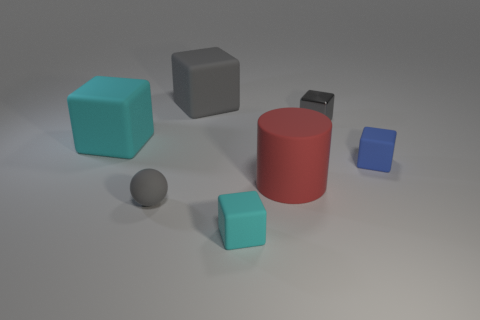Is the number of big brown metallic cylinders less than the number of blocks?
Your answer should be compact. Yes. Are there any other things that are the same color as the metallic object?
Give a very brief answer. Yes. What is the shape of the gray object that is in front of the red rubber cylinder?
Your answer should be very brief. Sphere. Do the small matte ball and the rubber cube that is on the right side of the red object have the same color?
Provide a short and direct response. No. Is the number of small cyan things that are behind the tiny matte sphere the same as the number of big gray matte blocks in front of the tiny metallic block?
Give a very brief answer. Yes. How many other objects are the same size as the gray metal block?
Provide a short and direct response. 3. The metallic block is what size?
Offer a terse response. Small. Do the big cylinder and the cyan cube behind the blue rubber block have the same material?
Your response must be concise. Yes. Is there a rubber object that has the same shape as the gray metallic thing?
Offer a terse response. Yes. What material is the cyan block that is the same size as the matte cylinder?
Your answer should be very brief. Rubber. 